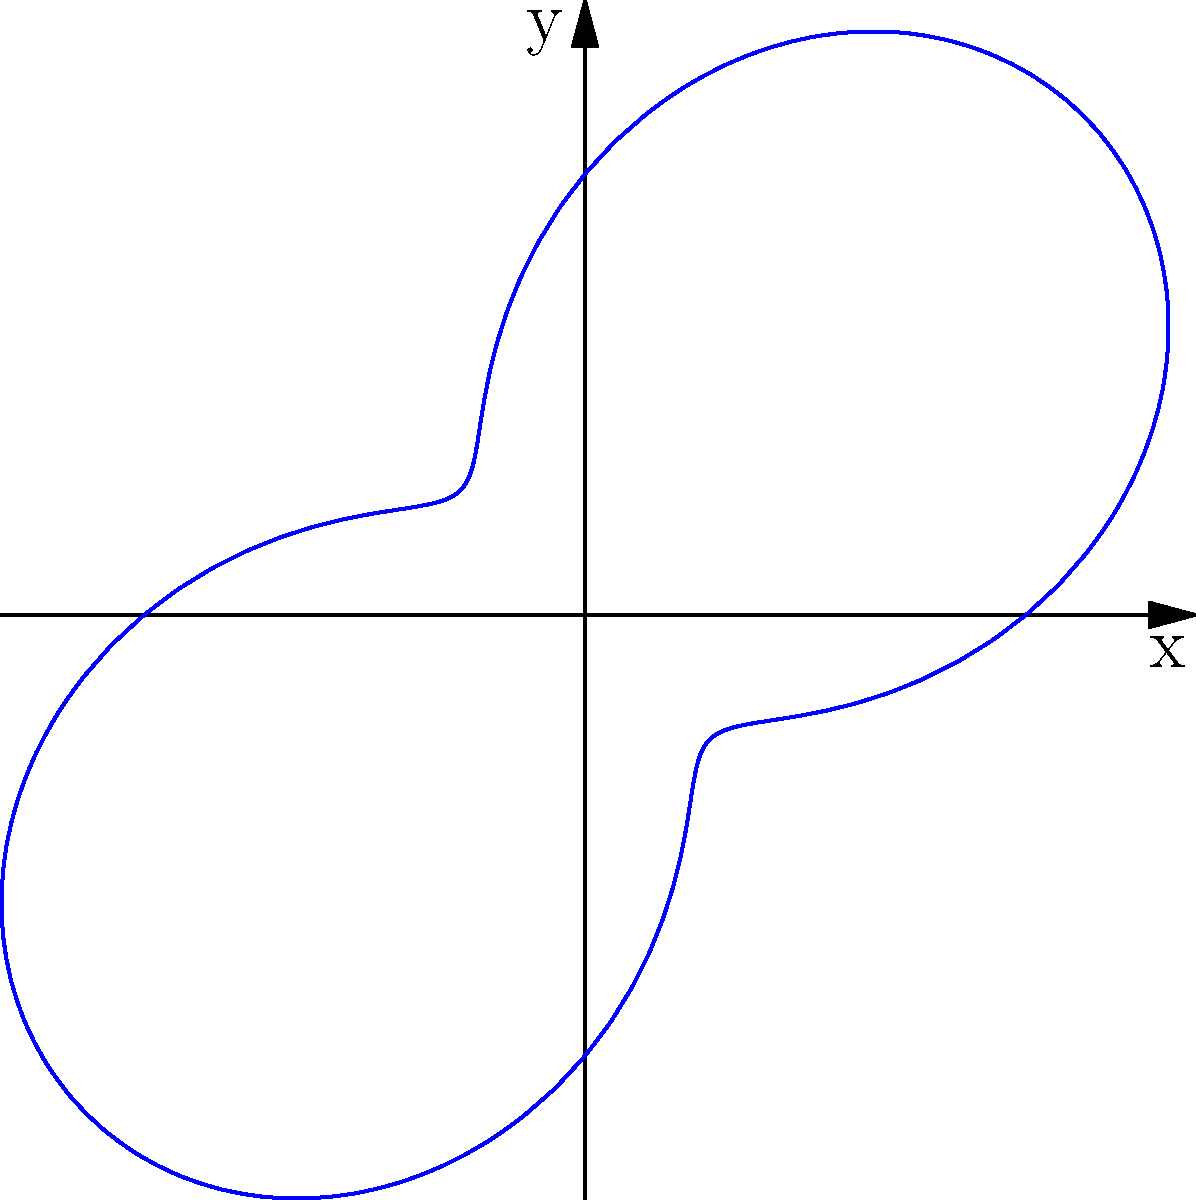The polar plot represents daily calorie intake for a child, where the radius is in calories and the angle represents time of day. The equation of the curve is $r = 500 + 300\sin(2\theta)$, where $\theta$ is in radians. Calculate the total calorie intake for the day, which is represented by the area enclosed by this curve. To find the area enclosed by a polar curve, we use the formula:

$$ A = \frac{1}{2} \int_{0}^{2\pi} r^2(\theta) d\theta $$

1) First, we square the given function:
   $r^2 = (500 + 300\sin(2\theta))^2 = 250000 + 300000\sin(2\theta) + 90000\sin^2(2\theta)$

2) Now, we integrate this function from 0 to $2\pi$:
   $$ A = \frac{1}{2} \int_{0}^{2\pi} (250000 + 300000\sin(2\theta) + 90000\sin^2(2\theta)) d\theta $$

3) Integrate each term:
   - $\int_{0}^{2\pi} 250000 d\theta = 250000 \theta |_{0}^{2\pi} = 500000\pi$
   - $\int_{0}^{2\pi} 300000\sin(2\theta) d\theta = -150000\cos(2\theta) |_{0}^{2\pi} = 0$
   - $\int_{0}^{2\pi} 90000\sin^2(2\theta) d\theta = 90000 (\frac{\theta}{2} - \frac{\sin(4\theta)}{4}) |_{0}^{2\pi} = 90000\pi$

4) Sum up the results and multiply by $\frac{1}{2}$:
   $$ A = \frac{1}{2} (500000\pi + 0 + 90000\pi) = 295000\pi $$

5) This gives us the area in square calories. To convert to total calories, we take the square root:
   $$ \sqrt{295000\pi} \approx 962 \text{ calories} $$
Answer: 962 calories 